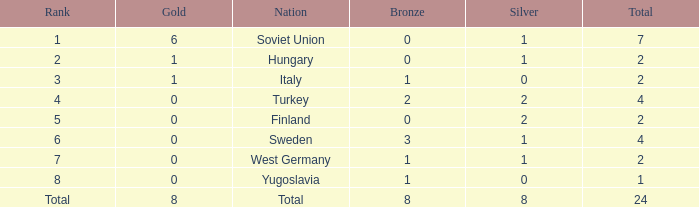Would you be able to parse every entry in this table? {'header': ['Rank', 'Gold', 'Nation', 'Bronze', 'Silver', 'Total'], 'rows': [['1', '6', 'Soviet Union', '0', '1', '7'], ['2', '1', 'Hungary', '0', '1', '2'], ['3', '1', 'Italy', '1', '0', '2'], ['4', '0', 'Turkey', '2', '2', '4'], ['5', '0', 'Finland', '0', '2', '2'], ['6', '0', 'Sweden', '3', '1', '4'], ['7', '0', 'West Germany', '1', '1', '2'], ['8', '0', 'Yugoslavia', '1', '0', '1'], ['Total', '8', 'Total', '8', '8', '24']]} What is the sum of Total, when Rank is 8, and when Bronze is less than 1? None. 